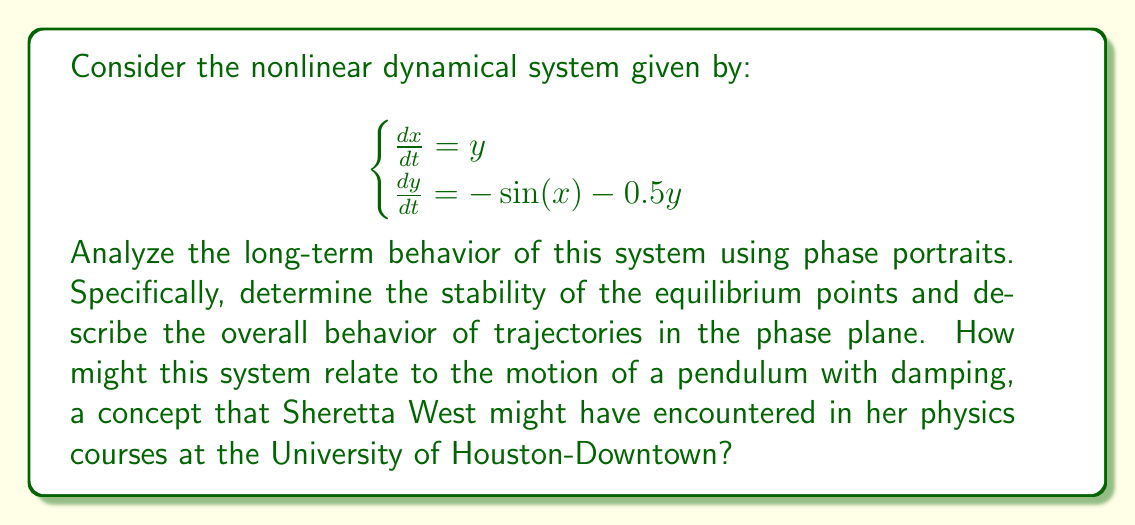Can you answer this question? Let's analyze this system step-by-step:

1) First, we need to find the equilibrium points. These occur when $\frac{dx}{dt} = \frac{dy}{dt} = 0$:

   $$\begin{cases}
   y = 0 \\
   -\sin(x) = 0
   \end{cases}$$

   This gives us equilibrium points at $(n\pi, 0)$ where $n$ is any integer.

2) To determine stability, we need to linearize the system around each equilibrium point. The Jacobian matrix is:

   $$J = \begin{bmatrix}
   0 & 1 \\
   -\cos(x) & -0.5
   \end{bmatrix}$$

3) At equilibrium points where $x = 2n\pi$, the Jacobian becomes:

   $$J = \begin{bmatrix}
   0 & 1 \\
   -1 & -0.5
   \end{bmatrix}$$

   The eigenvalues are $\lambda = -0.25 \pm i\sqrt{0.9375}$. Since the real parts are negative, these points are stable spiral points.

4) At equilibrium points where $x = (2n+1)\pi$, the Jacobian becomes:

   $$J = \begin{bmatrix}
   0 & 1 \\
   1 & -0.5
   \end{bmatrix}$$

   The eigenvalues are $\lambda = 0.25 \pm \sqrt{1.0625}$. Since one eigenvalue is positive, these points are saddle points.

5) The phase portrait will show:
   - Stable spiral points at $(0, 0)$, $(2\pi, 0)$, $(-2\pi, 0)$, etc.
   - Saddle points at $(\pi, 0)$, $(-\pi, 0)$, $(3\pi, 0)$, etc.
   - Trajectories spiraling into the stable points.
   - Separatrices connecting the saddle points.

6) This system is similar to a damped pendulum:
   - $x$ represents the angle of the pendulum.
   - $y$ represents the angular velocity.
   - The $-\sin(x)$ term represents the restoring gravitational force.
   - The $-0.5y$ term represents damping.

7) Long-term behavior:
   - Most trajectories will eventually spiral into the nearest stable equilibrium point.
   - This represents the pendulum coming to rest at its lowest point after oscillating.
   - The saddle points represent the unstable equilibrium of the pendulum pointing straight up.

[asy]
import graph;
size(200);
real f(real x, real y) {return y;}
real g(real x, real y) {return -sin(x)-0.5y;}
add(vectorfield(f,g,(-2pi,-3),(2pi,3),0.3,blue));
for(real x=-2pi; x<=2pi; x+=pi) {
  dot((x,0),red);
}
</asy]
Answer: The system has stable spiral points at $(2n\pi, 0)$ and saddle points at $((2n+1)\pi, 0)$. Most trajectories spiral into stable points, representing damped oscillations. 